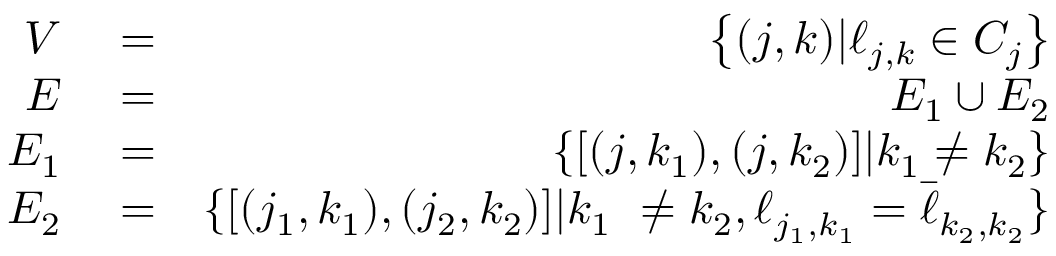<formula> <loc_0><loc_0><loc_500><loc_500>\begin{array} { r l r } { V } & = } & { \left \{ ( j , k ) | \ell _ { j , k } \in C _ { j } \right \} } \\ { E } & = } & { E _ { 1 } \cup E _ { 2 } } \\ { E _ { 1 } } & = } & { \left \{ [ ( j , k _ { 1 } ) , ( j , k _ { 2 } ) ] | k _ { 1 } \neq k _ { 2 } \right \} } \\ { E _ { 2 } } & = } & { \{ [ ( j _ { 1 } , k _ { 1 } ) , ( j _ { 2 } , k _ { 2 } ) ] | k _ { 1 } \ \neq k _ { 2 } , \ell _ { j _ { 1 } , k _ { 1 } } = \bar { \ell } _ { k _ { 2 } , k _ { 2 } } \} } \end{array}</formula> 